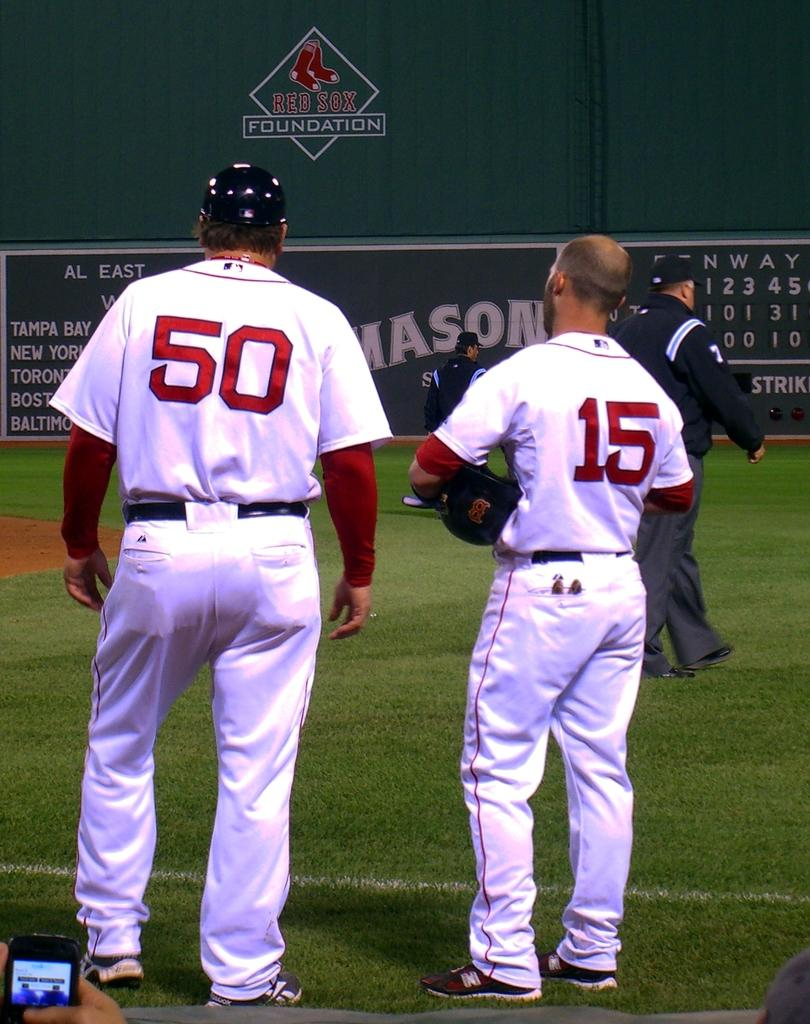<image>
Write a terse but informative summary of the picture. Two people from the Red Sox stand in front of an ad for the Red Sox Foundation. 